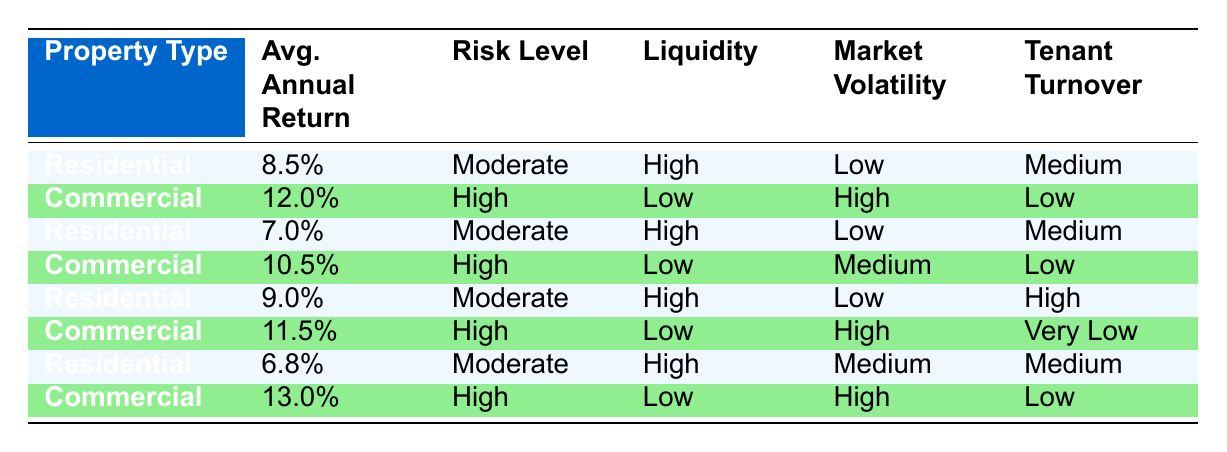What is the highest average annual return for residential properties? The table shows average annual returns for residential properties as 8.5%, 7.0%, 9.0%, and 6.8%. Among these values, 9.0% is the highest.
Answer: 9.0% What is the average annual return for commercial properties? The average annual returns for commercial properties in the table are 12.0%, 10.5%, 11.5%, and 13.0%. To find the average, we sum these values (12.0 + 10.5 + 11.5 + 13.0 = 47.0) and divide by the number of entries (47.0/4 = 11.75).
Answer: 11.75 Is it true that all commercial properties have low liquidity? The table indicates that all commercial properties show a liquidity level of "Low". Therefore, the statement is true based on the data.
Answer: Yes Which type of property has higher tenant turnover on average? For residential properties, tenant turnover is recorded as Medium, Medium, High, and Medium. For commercial properties, it's Low, Low, Very Low, and Low. The average turnover for residential properties is generally higher, so residential properties have a higher tenant turnover on average than commercial properties.
Answer: Residential What is the difference in average annual return between the highest commercial property return and the highest residential return? The highest average annual return for residential properties is 9.0% and for commercial properties is 13.0%. The difference between these two returns is calculated as 13.0% - 9.0% = 4.0%.
Answer: 4.0% How does the risk level of residential properties compare to that of commercial properties? The risk level for residential properties is consistently "Moderate", while for commercial properties, it is "High". This shows that commercial properties have a higher risk level compared to residential properties.
Answer: Higher risk for commercial properties What property type has the lowest average annual return? The recorded average annual returns for residential properties are 8.5%, 7.0%, 9.0%, and 6.8%. The lowest value is 6.8%. For commercial properties, the lowest return is 10.5%. Thus, residential properties have the lowest average annual return.
Answer: Residential Do commercial properties have high or low market volatility? The table categorizes market volatility for commercial properties as High in three instances and Medium in one instance. Therefore, it can be concluded that commercial properties typically have high market volatility.
Answer: High market volatility for commercial properties 